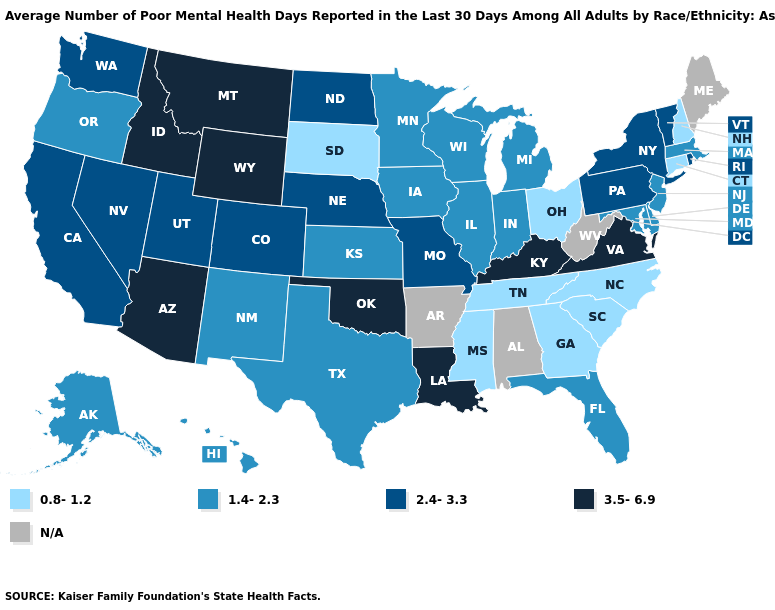Which states have the lowest value in the USA?
Concise answer only. Connecticut, Georgia, Mississippi, New Hampshire, North Carolina, Ohio, South Carolina, South Dakota, Tennessee. Name the states that have a value in the range 1.4-2.3?
Write a very short answer. Alaska, Delaware, Florida, Hawaii, Illinois, Indiana, Iowa, Kansas, Maryland, Massachusetts, Michigan, Minnesota, New Jersey, New Mexico, Oregon, Texas, Wisconsin. Which states hav the highest value in the Northeast?
Answer briefly. New York, Pennsylvania, Rhode Island, Vermont. What is the value of Wyoming?
Be succinct. 3.5-6.9. Name the states that have a value in the range 3.5-6.9?
Be succinct. Arizona, Idaho, Kentucky, Louisiana, Montana, Oklahoma, Virginia, Wyoming. Does the map have missing data?
Write a very short answer. Yes. What is the value of Maryland?
Answer briefly. 1.4-2.3. What is the lowest value in the USA?
Quick response, please. 0.8-1.2. Does North Dakota have the highest value in the USA?
Concise answer only. No. Does the first symbol in the legend represent the smallest category?
Quick response, please. Yes. What is the lowest value in the USA?
Concise answer only. 0.8-1.2. Name the states that have a value in the range 3.5-6.9?
Short answer required. Arizona, Idaho, Kentucky, Louisiana, Montana, Oklahoma, Virginia, Wyoming. Which states hav the highest value in the South?
Be succinct. Kentucky, Louisiana, Oklahoma, Virginia. What is the value of North Carolina?
Answer briefly. 0.8-1.2. 